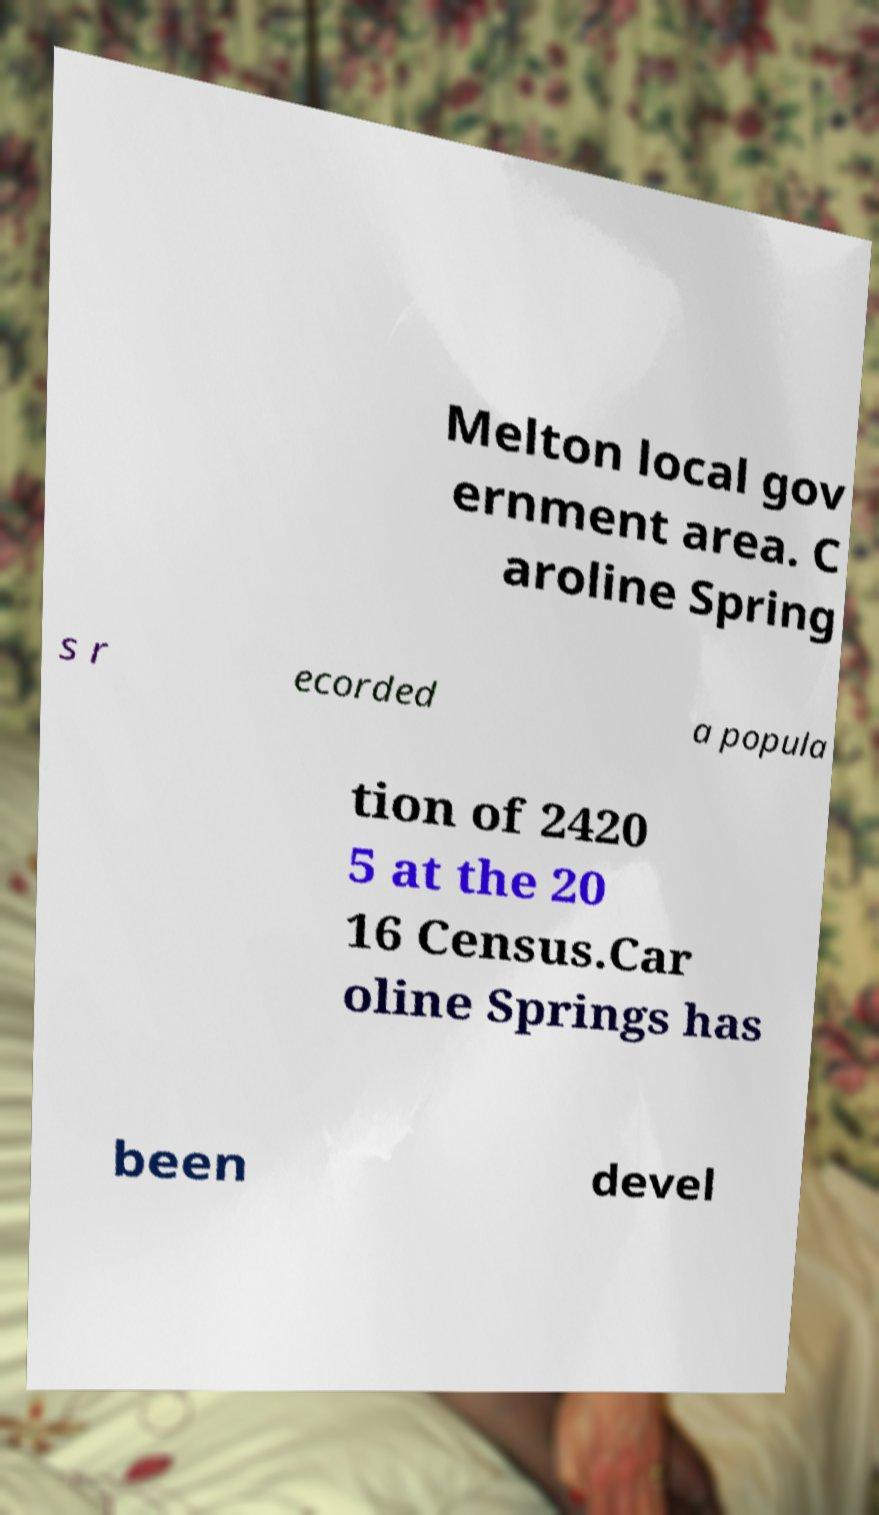What messages or text are displayed in this image? I need them in a readable, typed format. Melton local gov ernment area. C aroline Spring s r ecorded a popula tion of 2420 5 at the 20 16 Census.Car oline Springs has been devel 